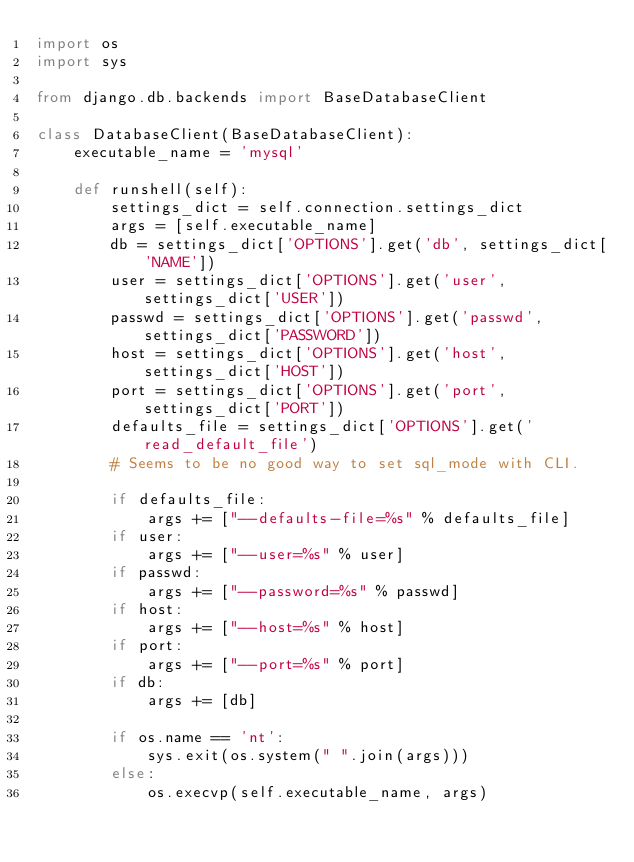<code> <loc_0><loc_0><loc_500><loc_500><_Python_>import os
import sys

from django.db.backends import BaseDatabaseClient

class DatabaseClient(BaseDatabaseClient):
    executable_name = 'mysql'

    def runshell(self):
        settings_dict = self.connection.settings_dict
        args = [self.executable_name]
        db = settings_dict['OPTIONS'].get('db', settings_dict['NAME'])
        user = settings_dict['OPTIONS'].get('user', settings_dict['USER'])
        passwd = settings_dict['OPTIONS'].get('passwd', settings_dict['PASSWORD'])
        host = settings_dict['OPTIONS'].get('host', settings_dict['HOST'])
        port = settings_dict['OPTIONS'].get('port', settings_dict['PORT'])
        defaults_file = settings_dict['OPTIONS'].get('read_default_file')
        # Seems to be no good way to set sql_mode with CLI.

        if defaults_file:
            args += ["--defaults-file=%s" % defaults_file]
        if user:
            args += ["--user=%s" % user]
        if passwd:
            args += ["--password=%s" % passwd]
        if host:
            args += ["--host=%s" % host]
        if port:
            args += ["--port=%s" % port]
        if db:
            args += [db]

        if os.name == 'nt':
            sys.exit(os.system(" ".join(args)))
        else:
            os.execvp(self.executable_name, args)

</code> 